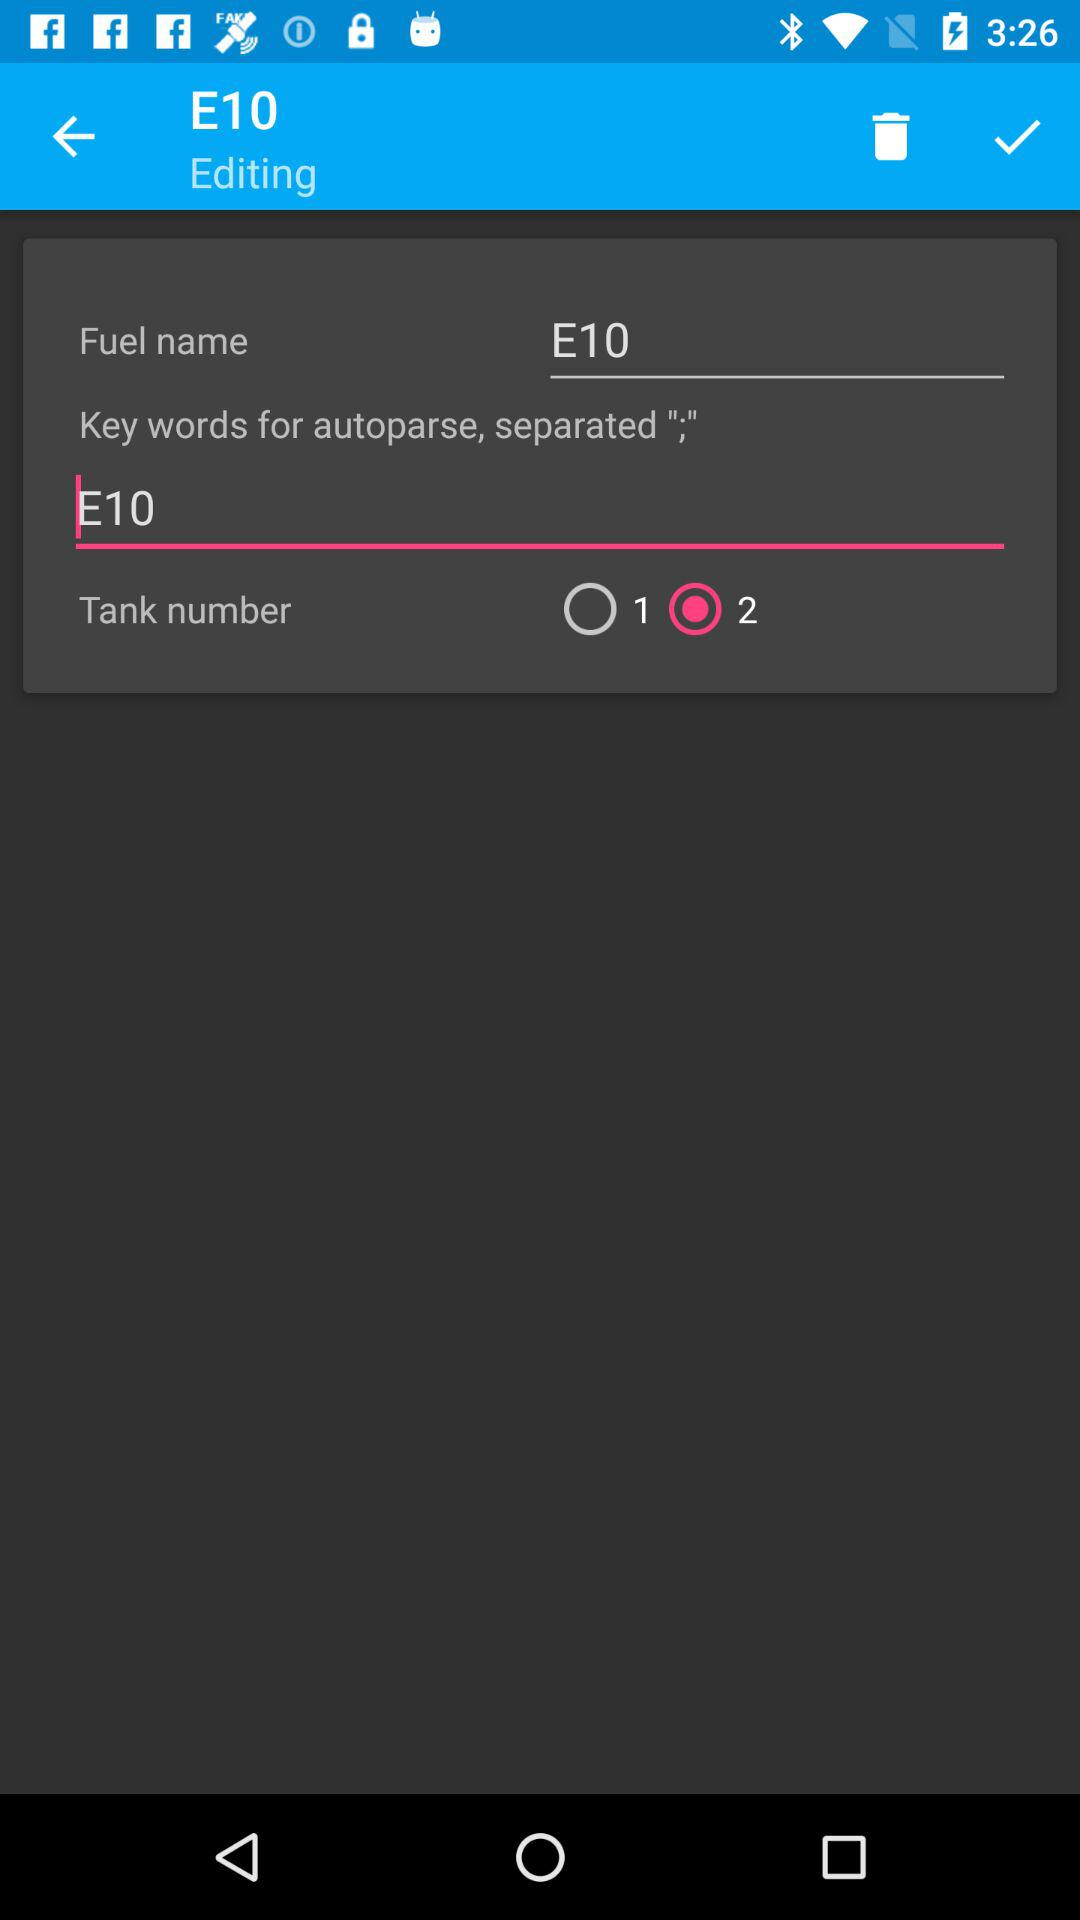What is the fuel name? The fuel name is E10. 